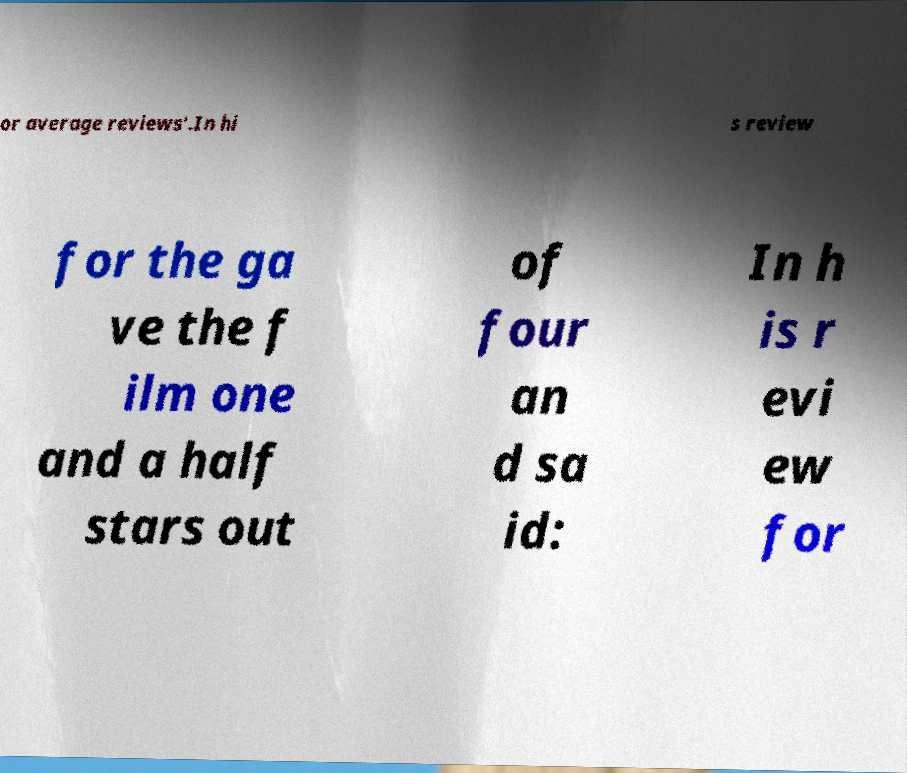Can you read and provide the text displayed in the image?This photo seems to have some interesting text. Can you extract and type it out for me? or average reviews'.In hi s review for the ga ve the f ilm one and a half stars out of four an d sa id: In h is r evi ew for 